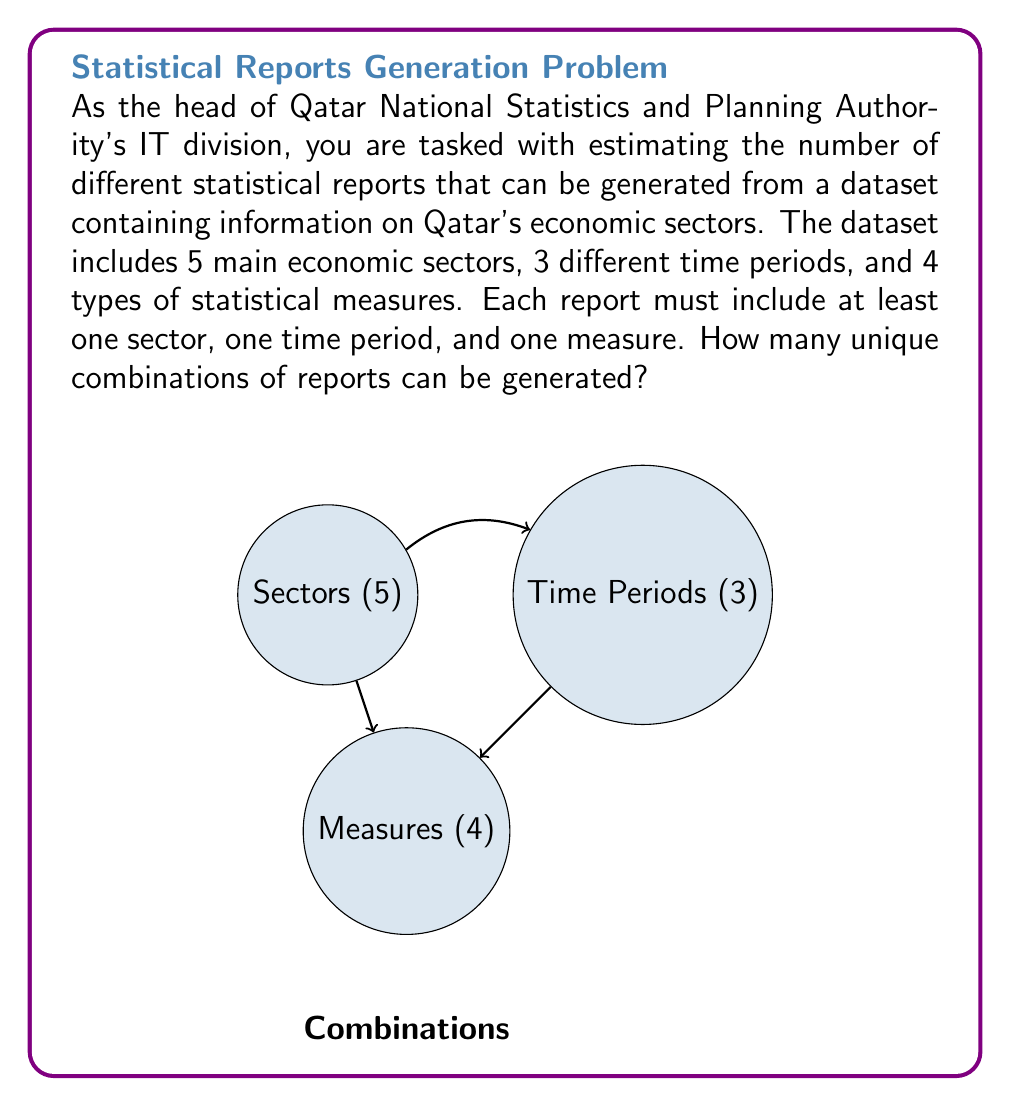Give your solution to this math problem. To solve this problem, we'll use the multiplication principle of combinatorics and the concept of power sets. Let's break it down step-by-step:

1) First, we need to consider that each component (sectors, time periods, and measures) can be present or absent in a report, except that at least one of each must be included.

2) For sectors, we have 5 choices, and each can be included or not. This gives us $2^5 = 32$ possibilities. However, we can't have zero sectors, so we subtract 1. Thus, we have $32 - 1 = 31$ possibilities for sectors.

3) Similarly, for time periods, we have 3 choices, giving $2^3 - 1 = 7$ possibilities (excluding the case where no time period is chosen).

4) For measures, we have 4 choices, giving $2^4 - 1 = 15$ possibilities (excluding the case where no measure is chosen).

5) Now, according to the multiplication principle, the total number of combinations is the product of these individual possibilities:

   $31 * 7 * 15 = 3,255$

6) However, this includes the case where all components are chosen, which we've counted multiple times (once for each component). We only want to count this case once, so we need to subtract the number of extra counts:

   $3,255 - 2 = 3,253$

Therefore, the total number of unique report combinations is 3,253.
Answer: 3,253 unique report combinations 